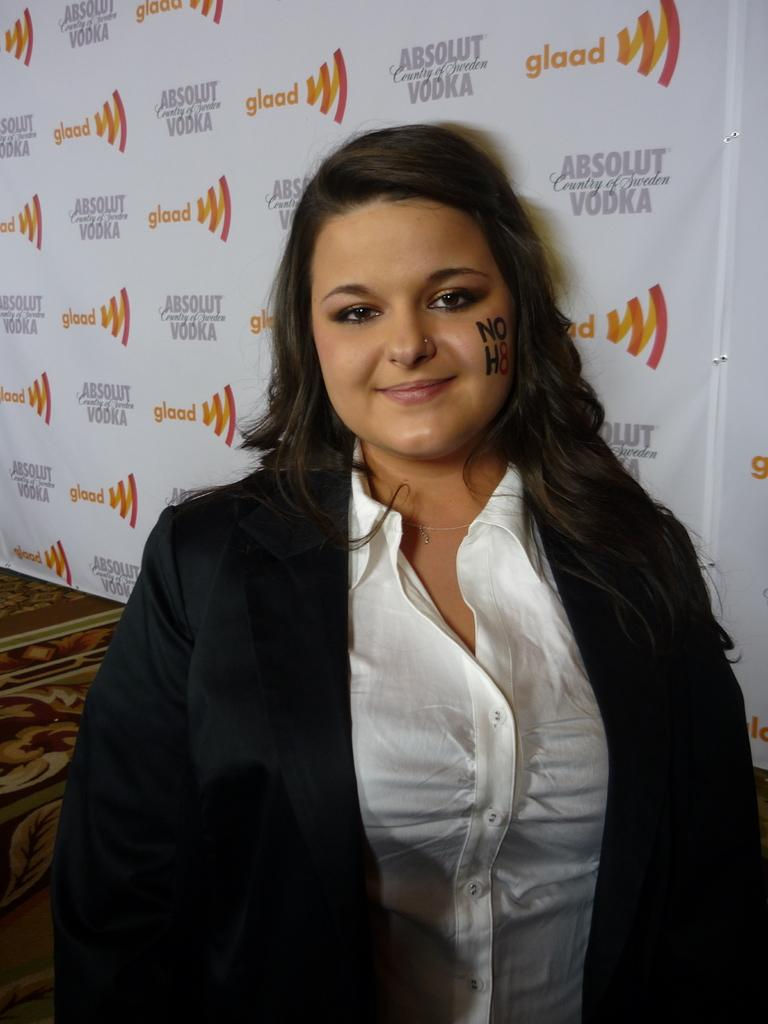Who is present in the image? There is a woman in the image. Where is the woman located in the image? The woman is standing at the bottom of the image. What is the woman wearing in the image? The woman is wearing a black color blazer. What can be seen in the background of the image? There is a wall poster in the background of the image. How many bees are flying around the woman in the image? There are no bees present in the image. What type of addition problem can be solved using the wall poster in the image? The wall poster in the image does not contain any addition problems, so it cannot be used to solve one. 